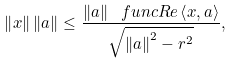Convert formula to latex. <formula><loc_0><loc_0><loc_500><loc_500>\left \| x \right \| \left \| a \right \| \leq \frac { \left \| a \right \| \ f u n c { R e } \left \langle x , a \right \rangle } { \sqrt { \left \| a \right \| ^ { 2 } - r ^ { 2 } } } ,</formula> 